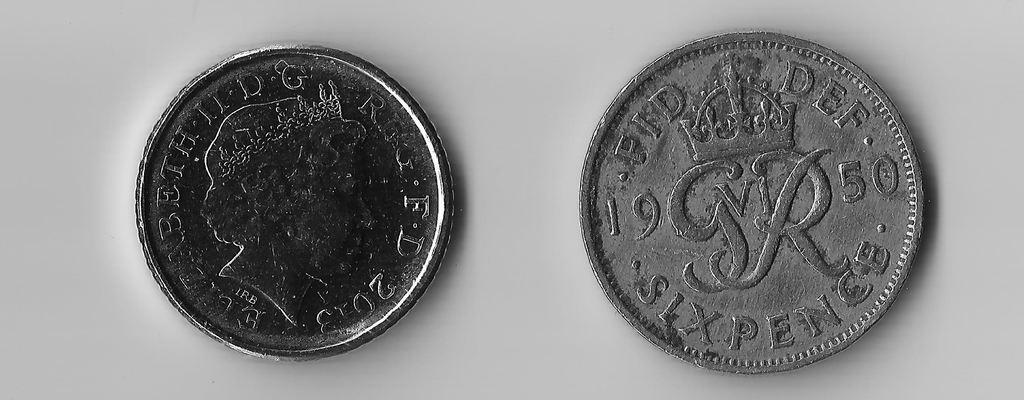<image>
Share a concise interpretation of the image provided. Two silver coins that say Beth II DG are on a white surface. 